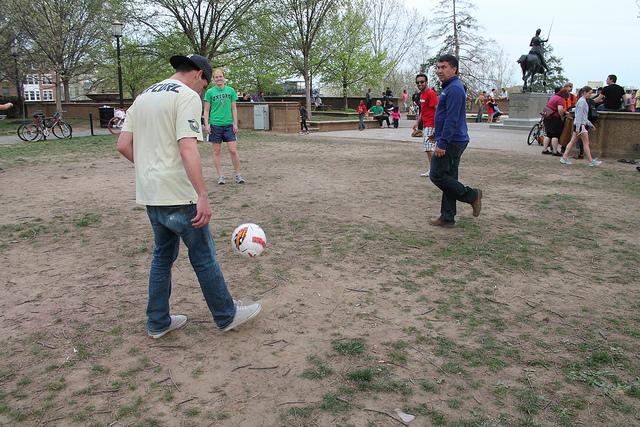What game are they playing?
Write a very short answer. Soccer. Is the person standing?
Short answer required. Yes. They are riding a train?
Quick response, please. No. What kind of ball is that in the sand?
Write a very short answer. Soccer. How can you tell it's Autumn?
Quick response, please. Trees. What sport is this team playing?
Concise answer only. Soccer. What sport is shown?
Short answer required. Soccer. What are the men playing?
Concise answer only. Soccer. What is the man on the right trying to catch?
Be succinct. Soccer ball. Are all the guys standing?
Be succinct. Yes. How many people are in the scene?
Be succinct. 15. Where is the person he is playing with?
Answer briefly. In front of him. Are they sitting at a park?
Quick response, please. No. How many people are wearing shorts?
Answer briefly. 2. Which side is the person with a cap?
Concise answer only. Left. Are the men playing basketball?
Be succinct. No. What are they playing?
Concise answer only. Soccer. What is on the air?
Be succinct. Ball. Is this the proper way to play with this object?
Be succinct. Yes. What color is the ball?
Write a very short answer. White. What sport is depicted?
Keep it brief. Soccer. What is the boy about to throw?
Quick response, please. Ball. Is the man calling someone?
Short answer required. No. What color is the photo?
Keep it brief. Color. 